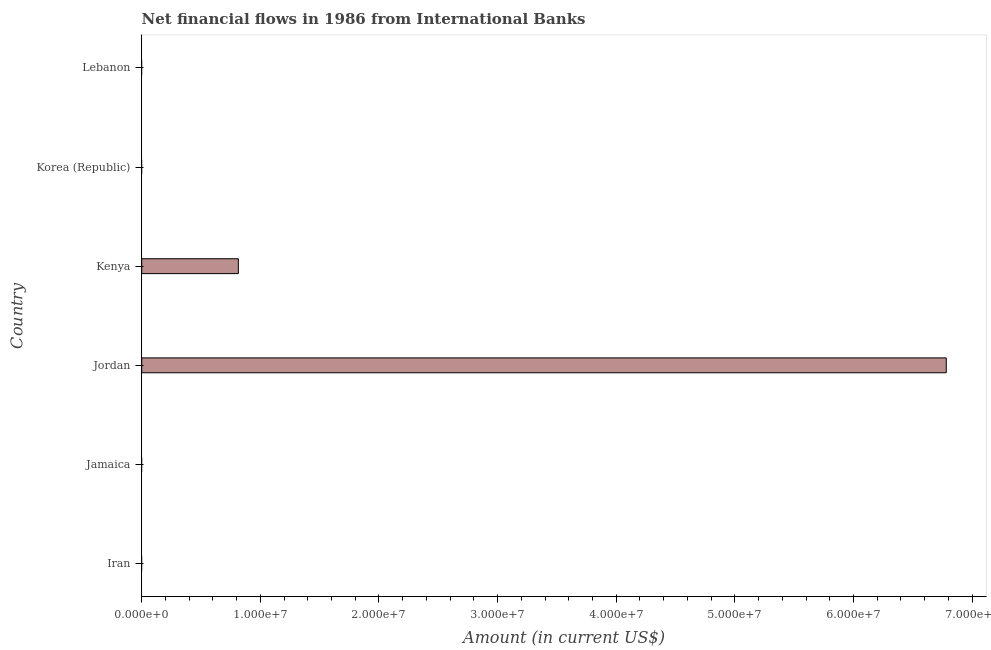What is the title of the graph?
Provide a short and direct response. Net financial flows in 1986 from International Banks. What is the label or title of the Y-axis?
Offer a terse response. Country. What is the net financial flows from ibrd in Lebanon?
Your response must be concise. 0. Across all countries, what is the maximum net financial flows from ibrd?
Keep it short and to the point. 6.78e+07. Across all countries, what is the minimum net financial flows from ibrd?
Provide a short and direct response. 0. In which country was the net financial flows from ibrd maximum?
Keep it short and to the point. Jordan. What is the sum of the net financial flows from ibrd?
Your answer should be compact. 7.60e+07. What is the difference between the net financial flows from ibrd in Jordan and Kenya?
Keep it short and to the point. 5.97e+07. What is the average net financial flows from ibrd per country?
Make the answer very short. 1.27e+07. What is the difference between the highest and the lowest net financial flows from ibrd?
Your response must be concise. 6.78e+07. Are all the bars in the graph horizontal?
Offer a terse response. Yes. How many countries are there in the graph?
Your answer should be very brief. 6. What is the Amount (in current US$) in Jamaica?
Your answer should be very brief. 0. What is the Amount (in current US$) in Jordan?
Provide a succinct answer. 6.78e+07. What is the Amount (in current US$) in Kenya?
Provide a short and direct response. 8.14e+06. What is the Amount (in current US$) in Korea (Republic)?
Your answer should be compact. 0. What is the difference between the Amount (in current US$) in Jordan and Kenya?
Ensure brevity in your answer.  5.97e+07. What is the ratio of the Amount (in current US$) in Jordan to that in Kenya?
Your answer should be very brief. 8.33. 